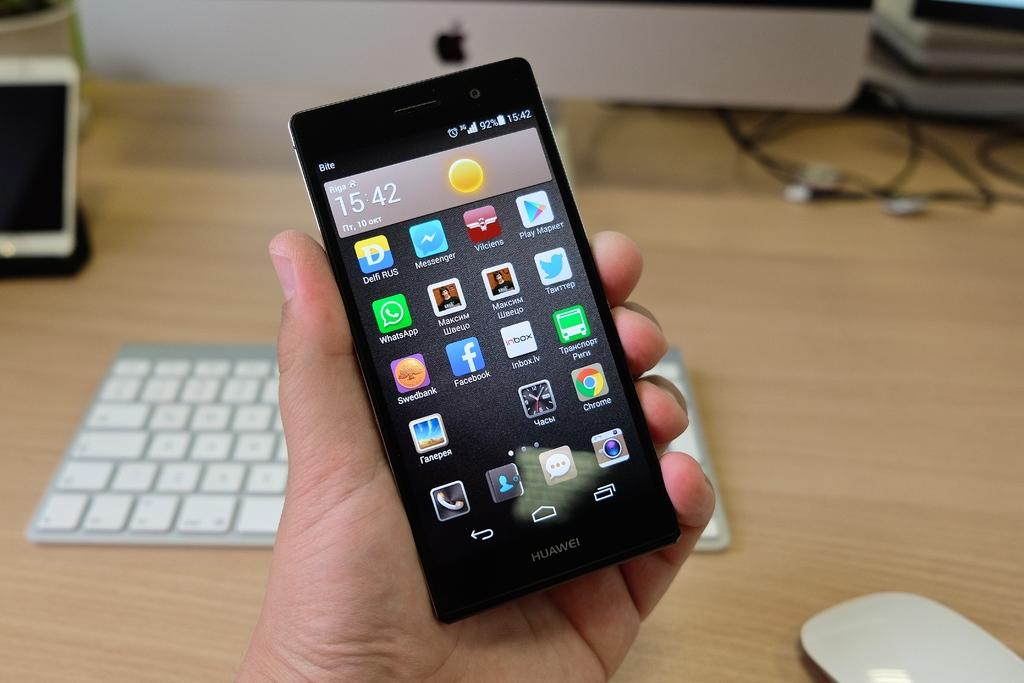<image>
Create a compact narrative representing the image presented. A Huawei brand phone displays the time of 15:42. 